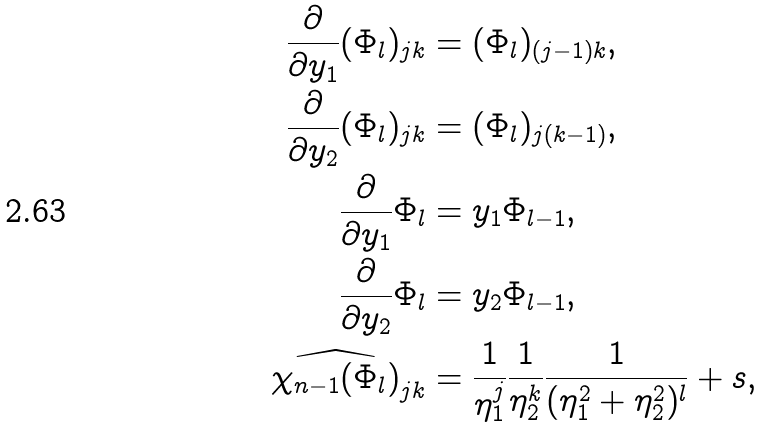Convert formula to latex. <formula><loc_0><loc_0><loc_500><loc_500>\frac { \partial } { \partial y _ { 1 } } ( \Phi _ { l } ) _ { j k } & = ( \Phi _ { l } ) _ { ( j - 1 ) k } , \\ \frac { \partial } { \partial y _ { 2 } } ( \Phi _ { l } ) _ { j k } & = ( \Phi _ { l } ) _ { j ( k - 1 ) } , \\ \frac { \partial } { \partial y _ { 1 } } \Phi _ { l } & = y _ { 1 } \Phi _ { l - 1 } , \\ \frac { \partial } { \partial y _ { 2 } } \Phi _ { l } & = y _ { 2 } \Phi _ { l - 1 } , \\ \widehat { \chi _ { n - 1 } ( \Phi _ { l } ) } _ { j k } & = \frac { 1 } { \eta _ { 1 } ^ { j } } \frac { 1 } { \eta _ { 2 } ^ { k } } \frac { 1 } { ( \eta _ { 1 } ^ { 2 } + \eta _ { 2 } ^ { 2 } ) ^ { l } } + s ,</formula> 